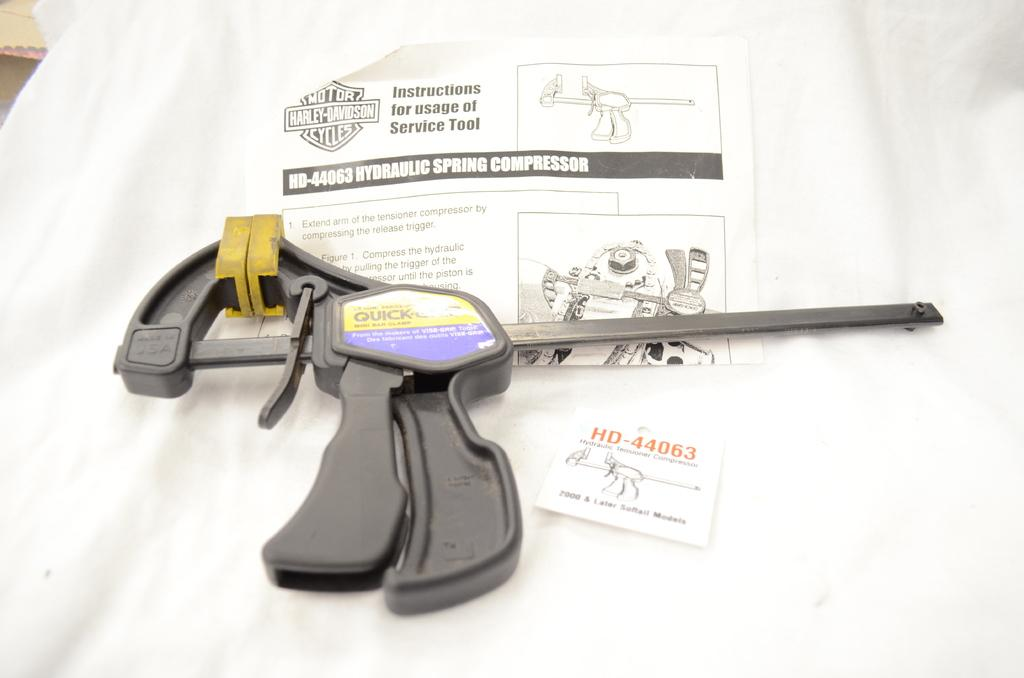What is the main object in the image? There is a hydraulic spring compressor in the image. What color is the cover of the hydraulic spring compressor? The hydraulic spring compressor has a white cover. Are there any additional features on the white cover? Yes, there are stickers on the white cover of the hydraulic spring compressor. How many cans of soda are placed on the hydraulic spring compressor in the image? There are no cans of soda present in the image; it features a hydraulic spring compressor with a white cover and stickers. What type of rings can be seen on the hydraulic spring compressor in the image? There are no rings visible on the hydraulic spring compressor in the image. 